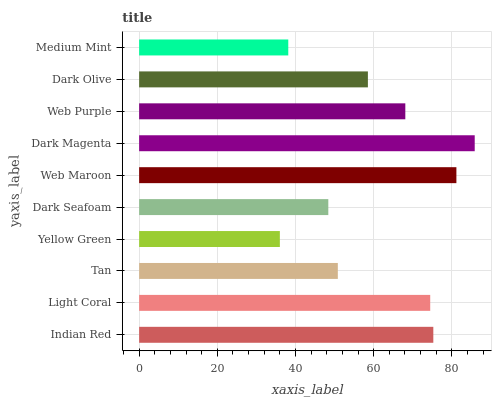Is Yellow Green the minimum?
Answer yes or no. Yes. Is Dark Magenta the maximum?
Answer yes or no. Yes. Is Light Coral the minimum?
Answer yes or no. No. Is Light Coral the maximum?
Answer yes or no. No. Is Indian Red greater than Light Coral?
Answer yes or no. Yes. Is Light Coral less than Indian Red?
Answer yes or no. Yes. Is Light Coral greater than Indian Red?
Answer yes or no. No. Is Indian Red less than Light Coral?
Answer yes or no. No. Is Web Purple the high median?
Answer yes or no. Yes. Is Dark Olive the low median?
Answer yes or no. Yes. Is Medium Mint the high median?
Answer yes or no. No. Is Dark Seafoam the low median?
Answer yes or no. No. 